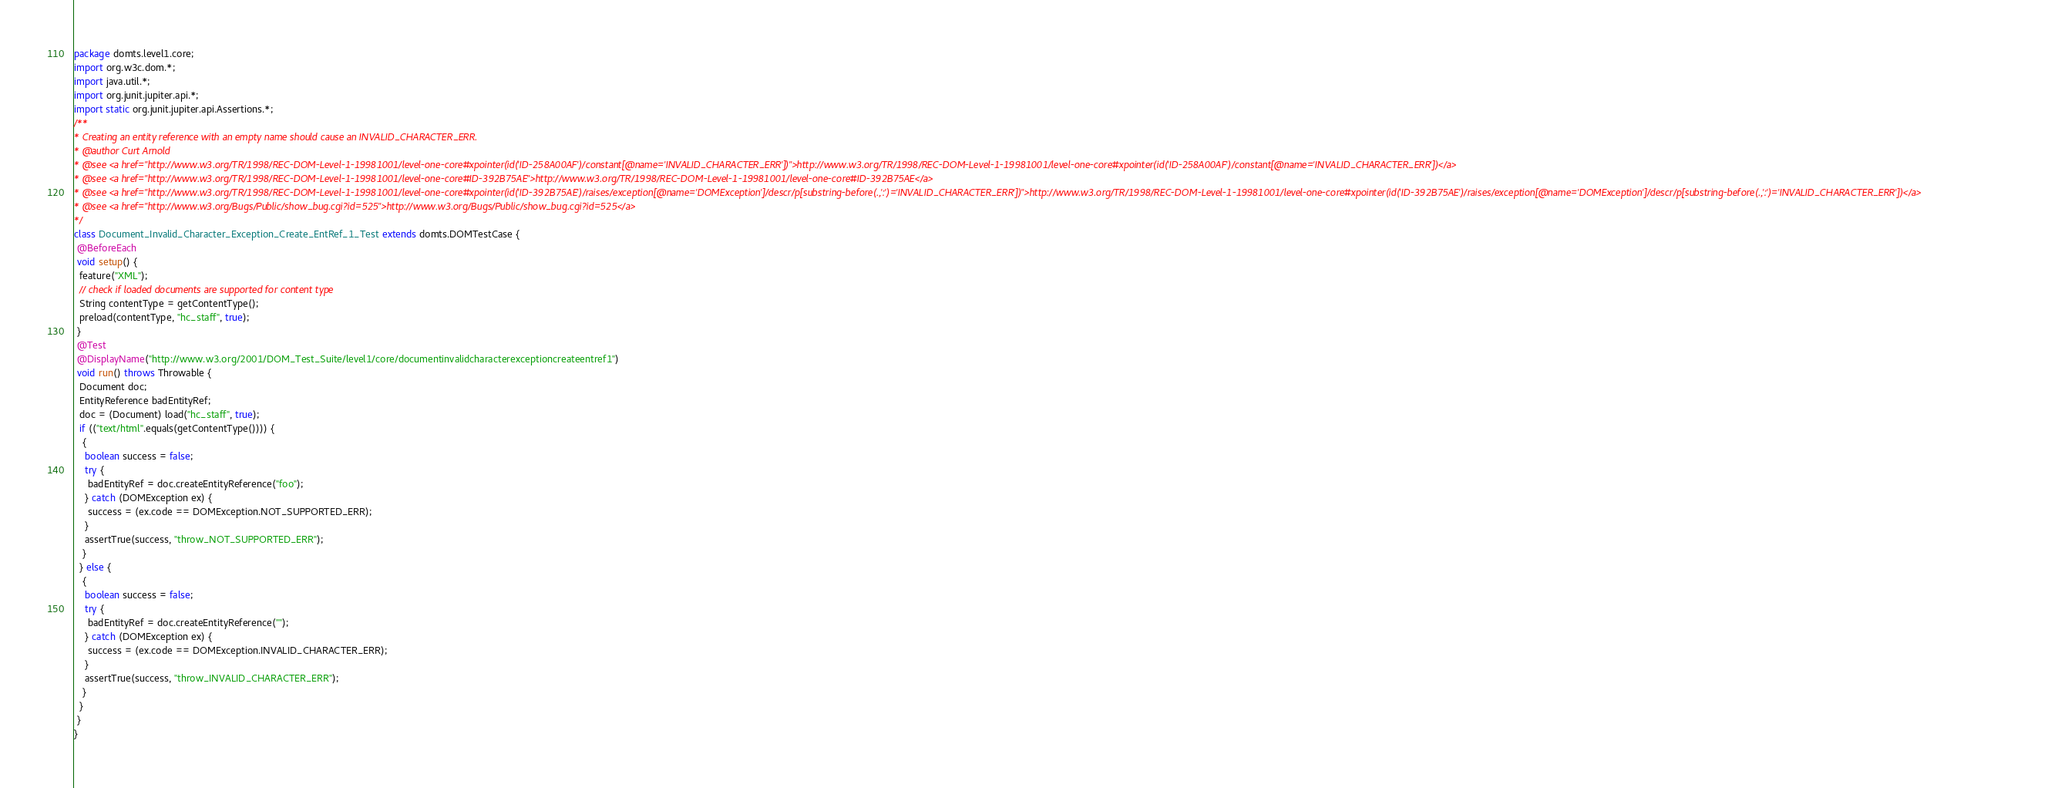Convert code to text. <code><loc_0><loc_0><loc_500><loc_500><_Java_>package domts.level1.core;
import org.w3c.dom.*;
import java.util.*;
import org.junit.jupiter.api.*;
import static org.junit.jupiter.api.Assertions.*;
/**
* Creating an entity reference with an empty name should cause an INVALID_CHARACTER_ERR.
* @author Curt Arnold
* @see <a href="http://www.w3.org/TR/1998/REC-DOM-Level-1-19981001/level-one-core#xpointer(id('ID-258A00AF')/constant[@name='INVALID_CHARACTER_ERR'])">http://www.w3.org/TR/1998/REC-DOM-Level-1-19981001/level-one-core#xpointer(id('ID-258A00AF')/constant[@name='INVALID_CHARACTER_ERR'])</a>
* @see <a href="http://www.w3.org/TR/1998/REC-DOM-Level-1-19981001/level-one-core#ID-392B75AE">http://www.w3.org/TR/1998/REC-DOM-Level-1-19981001/level-one-core#ID-392B75AE</a>
* @see <a href="http://www.w3.org/TR/1998/REC-DOM-Level-1-19981001/level-one-core#xpointer(id('ID-392B75AE')/raises/exception[@name='DOMException']/descr/p[substring-before(.,':')='INVALID_CHARACTER_ERR'])">http://www.w3.org/TR/1998/REC-DOM-Level-1-19981001/level-one-core#xpointer(id('ID-392B75AE')/raises/exception[@name='DOMException']/descr/p[substring-before(.,':')='INVALID_CHARACTER_ERR'])</a>
* @see <a href="http://www.w3.org/Bugs/Public/show_bug.cgi?id=525">http://www.w3.org/Bugs/Public/show_bug.cgi?id=525</a>
*/
class Document_Invalid_Character_Exception_Create_EntRef_1_Test extends domts.DOMTestCase {
 @BeforeEach
 void setup() {
  feature("XML");
  // check if loaded documents are supported for content type
  String contentType = getContentType();
  preload(contentType, "hc_staff", true);
 }
 @Test
 @DisplayName("http://www.w3.org/2001/DOM_Test_Suite/level1/core/documentinvalidcharacterexceptioncreateentref1")
 void run() throws Throwable {
  Document doc;
  EntityReference badEntityRef;
  doc = (Document) load("hc_staff", true);
  if (("text/html".equals(getContentType()))) {
   {
    boolean success = false;
    try {
     badEntityRef = doc.createEntityReference("foo");
    } catch (DOMException ex) {
     success = (ex.code == DOMException.NOT_SUPPORTED_ERR);
    }
    assertTrue(success, "throw_NOT_SUPPORTED_ERR");
   }
  } else {
   {
    boolean success = false;
    try {
     badEntityRef = doc.createEntityReference("");
    } catch (DOMException ex) {
     success = (ex.code == DOMException.INVALID_CHARACTER_ERR);
    }
    assertTrue(success, "throw_INVALID_CHARACTER_ERR");
   }
  }
 }
}</code> 